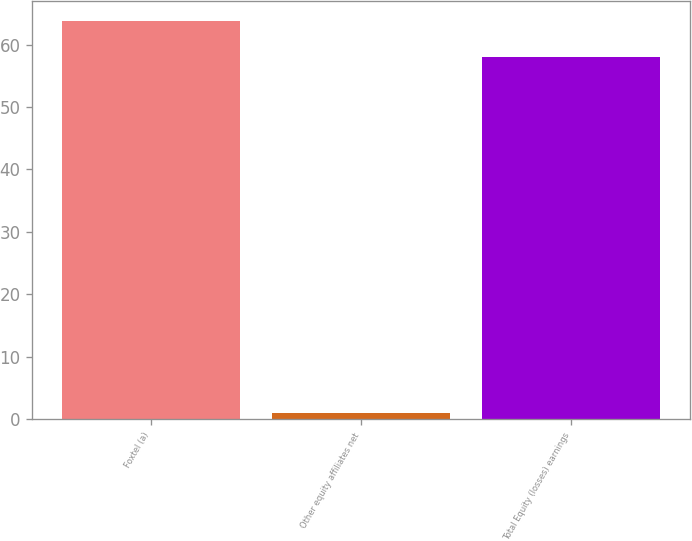Convert chart to OTSL. <chart><loc_0><loc_0><loc_500><loc_500><bar_chart><fcel>Foxtel (a)<fcel>Other equity affiliates net<fcel>Total Equity (losses) earnings<nl><fcel>63.8<fcel>1<fcel>58<nl></chart> 